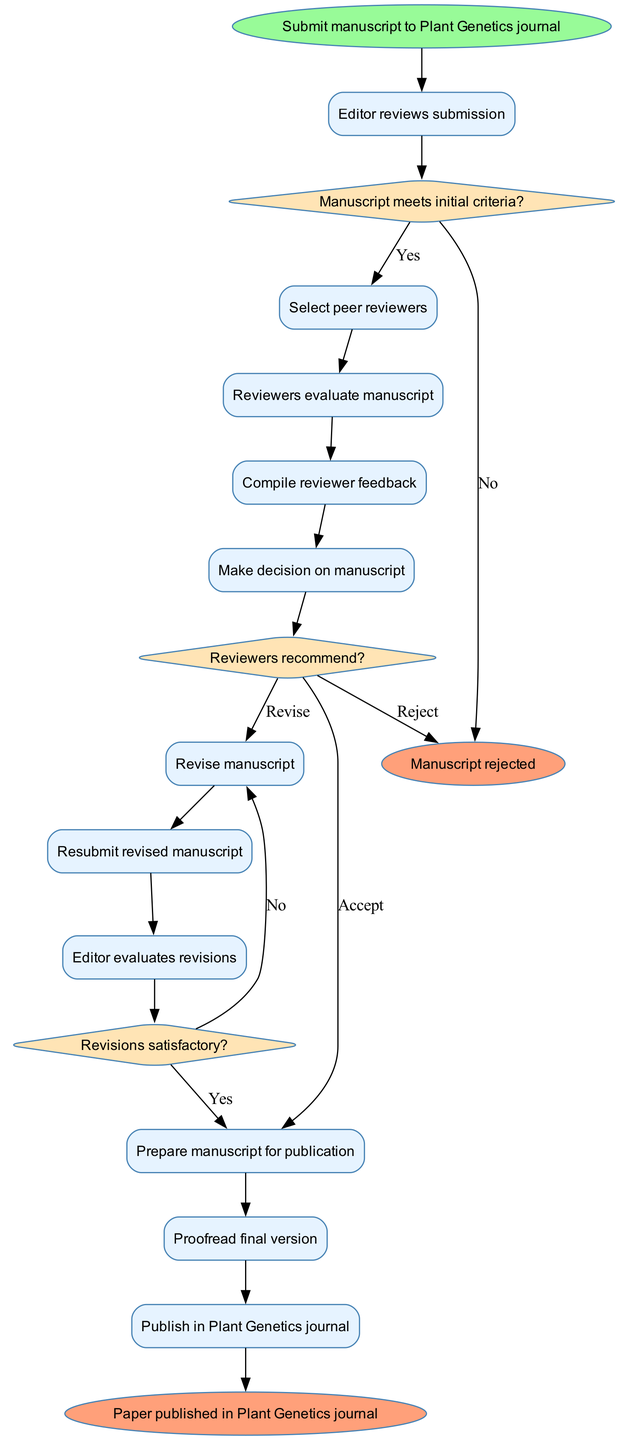What is the first activity in the process? The process starts with the initial node labeled 'Submit manuscript to Plant Genetics journal', which is the first activity in the diagram.
Answer: Submit manuscript to Plant Genetics journal How many decision points are present in the diagram? There are three decision points in the diagram, each represented by a diamond-shaped node labeled with questions.
Answer: 3 What does the editor do after reviewing the manuscript? After the editor reviews the submission, the next step is to 'Select peer reviewers', which follows the editor's review activity.
Answer: Select peer reviewers What happens if the manuscript does not meet the initial criteria? If the manuscript does not meet the initial criteria, the process flows to an end node labeled 'Manuscript rejected'.
Answer: Manuscript rejected What is the final step before publication? The final step before publication in the diagram is 'Proofread final version', which is the last activity before reaching the published state.
Answer: Proofread final version What options do reviewers have when making their recommendation? Reviewers can either recommend to 'Accept', 'Revise', or 'Reject' the manuscript, which are the options provided at the decision point.
Answer: Accept, Revise, Reject What is the flow of activities after revisions are made? After revisions are made, the flow goes to 'Resubmit revised manuscript', then 'Editor evaluates revisions', and it continues until 'Prepare manuscript for publication' if satisfactory.
Answer: Resubmit revised manuscript If revisions are deemed satisfactory, which activity follows? If the revisions are deemed satisfactory, the next activity is 'Prepare manuscript for publication', which occurs after the editor evaluates revisions.
Answer: Prepare manuscript for publication 